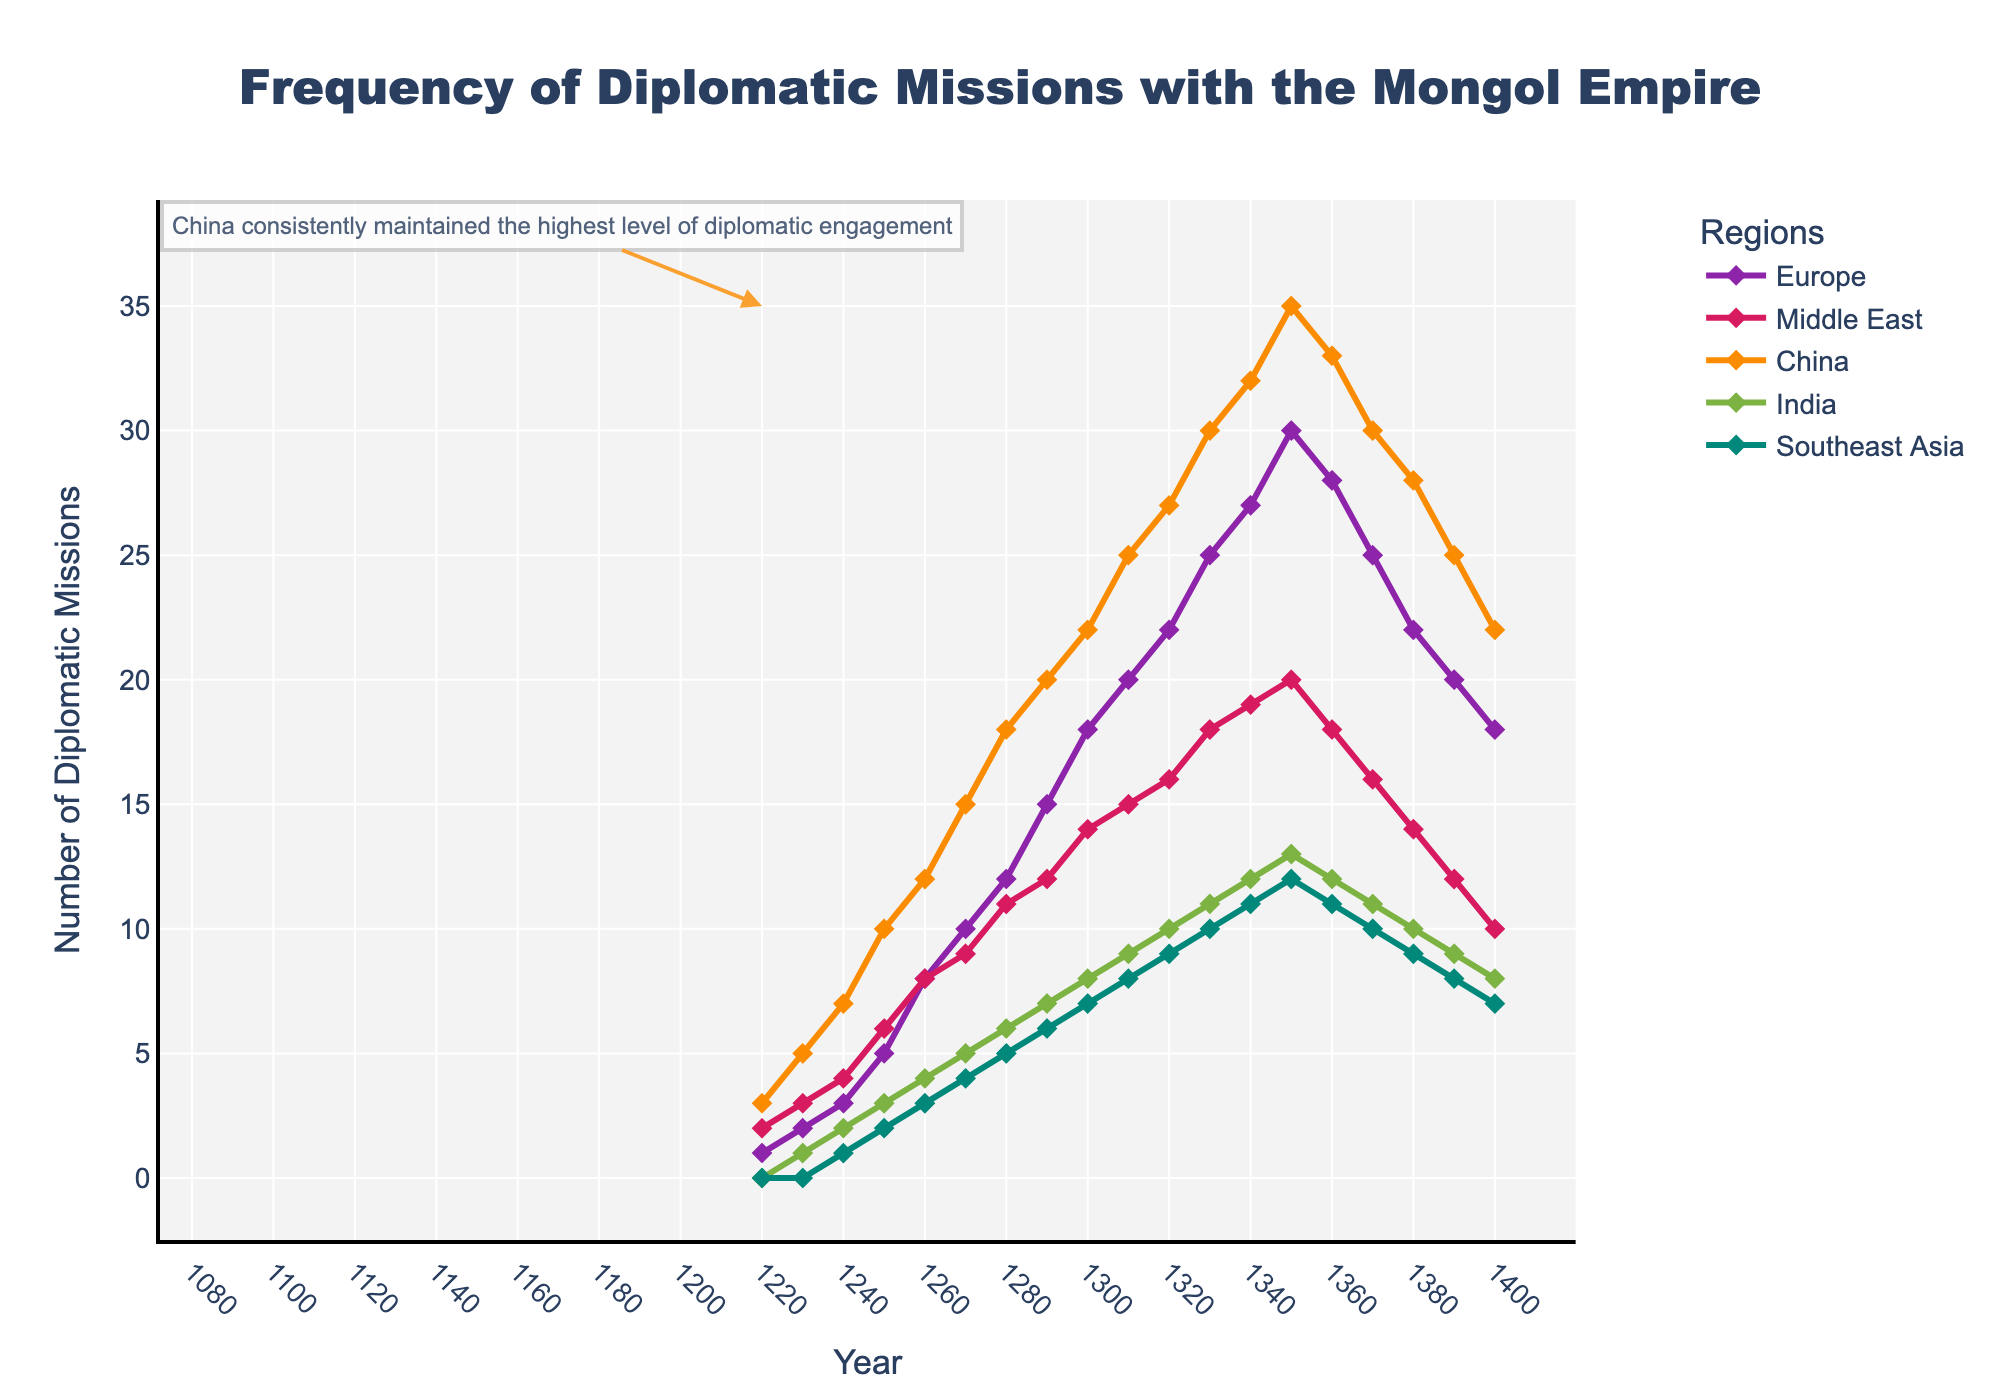Which region had the highest number of diplomatic missions in 1350? China had 35 diplomatic missions in 1350, which is higher than any other region.
Answer: China How did the frequency of diplomatic missions to Europe change between 1220 and 1360? In 1220, Europe had 1 diplomatic mission and by 1360, it increased to 28, showing a steady increment over this period.
Answer: Increased In which decade did Europe surpass 20 diplomatic missions? Europe surpassed 20 diplomatic missions in the 1320s, reaching 22.
Answer: 1320 What is the combined number of diplomatic missions to all regions in 1270? The number of diplomatic missions in 1270 were: Europe (10), Middle East (9), China (15), India (5), and Southeast Asia (4). The sum is 10 + 9 + 15 + 5 + 4 = 43.
Answer: 43 By how much did the frequency of diplomatic missions to the Middle East decrease from 1350 to 1390? In 1350, the Middle East had 20 missions, and in 1390 it had 12. The decrease is 20 - 12 = 8 missions.
Answer: 8 How does the number of diplomatic missions to India in 1300 compare to that in 1400? The number of diplomatic missions to India in 1300 was 8 and in 1400 it remained the same at 8, indicating no change in frequency.
Answer: No change Looking at the trend, which region's diplomatic missions seem to have peaked around 1350 and then declined? Europe reached its highest number of 30 missions around 1350 and then the numbers started to decline afterward.
Answer: Europe Which region had a consistent increase in diplomatic missions every decade from 1220 to 1340? China consistently increased its diplomatic missions every decade from 1220 (3 missions) to 1340 (32 missions).
Answer: China Between which two decades did Southeast Asia show the biggest increase in diplomatic missions? The biggest increase for Southeast Asia occurred between 1250 (2 missions) and 1260 (3 missions), with an increase of 1.
Answer: 1250 and 1260 